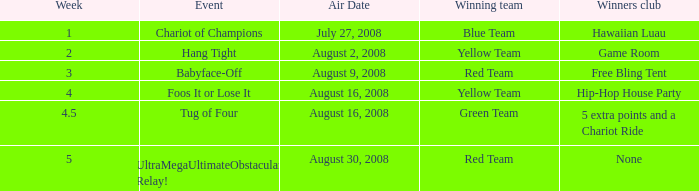Which conquerors club has an event of grip firmly? Game Room. 